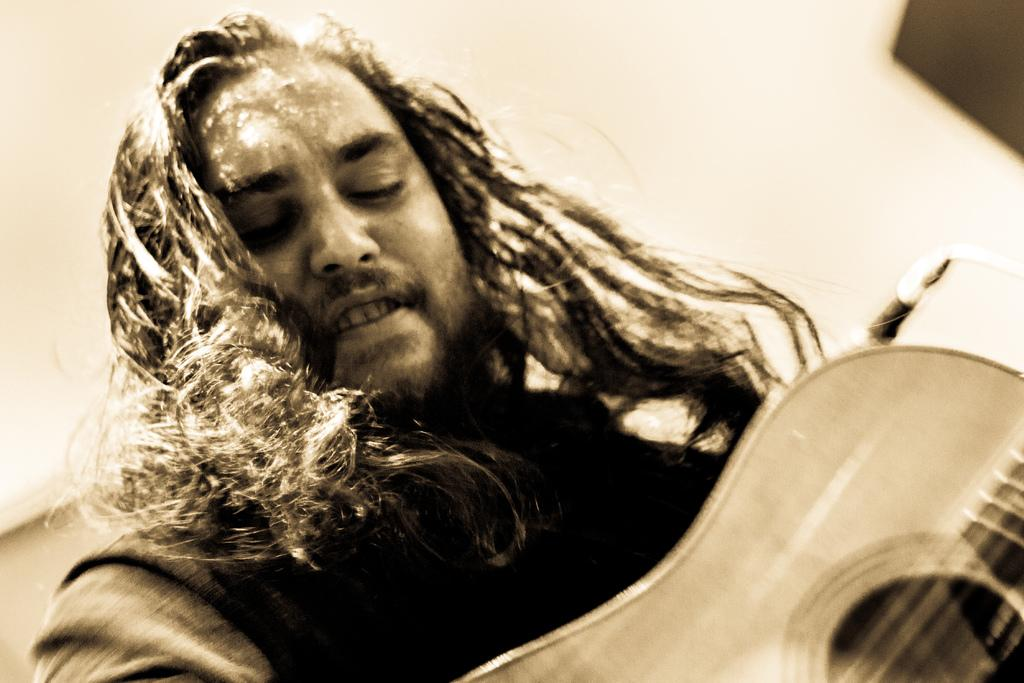Who or what is the main subject in the image? There is a person in the image. What is the person holding in the image? The person is holding a guitar. Can you describe the person's appearance? The person has long hair. What other object can be seen in the image related to the person's activity? There is a microphone behind the person. What type of engine is visible in the image? There is no engine present in the image. How does the person's voice sound in the image? The image does not provide any information about the person's voice. 